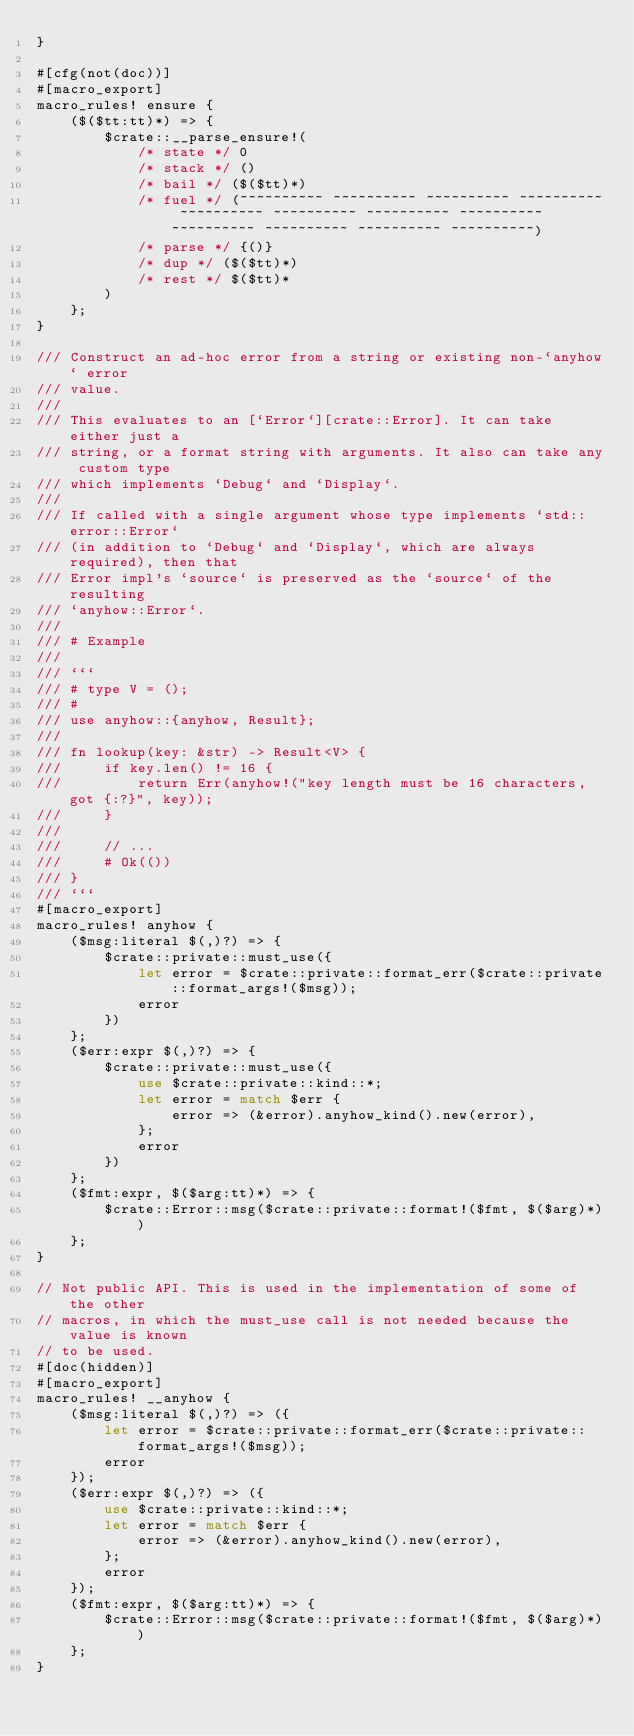<code> <loc_0><loc_0><loc_500><loc_500><_Rust_>}

#[cfg(not(doc))]
#[macro_export]
macro_rules! ensure {
    ($($tt:tt)*) => {
        $crate::__parse_ensure!(
            /* state */ 0
            /* stack */ ()
            /* bail */ ($($tt)*)
            /* fuel */ (~~~~~~~~~~ ~~~~~~~~~~ ~~~~~~~~~~ ~~~~~~~~~~ ~~~~~~~~~~ ~~~~~~~~~~ ~~~~~~~~~~ ~~~~~~~~~~ ~~~~~~~~~~ ~~~~~~~~~~ ~~~~~~~~~~ ~~~~~~~~~~)
            /* parse */ {()}
            /* dup */ ($($tt)*)
            /* rest */ $($tt)*
        )
    };
}

/// Construct an ad-hoc error from a string or existing non-`anyhow` error
/// value.
///
/// This evaluates to an [`Error`][crate::Error]. It can take either just a
/// string, or a format string with arguments. It also can take any custom type
/// which implements `Debug` and `Display`.
///
/// If called with a single argument whose type implements `std::error::Error`
/// (in addition to `Debug` and `Display`, which are always required), then that
/// Error impl's `source` is preserved as the `source` of the resulting
/// `anyhow::Error`.
///
/// # Example
///
/// ```
/// # type V = ();
/// #
/// use anyhow::{anyhow, Result};
///
/// fn lookup(key: &str) -> Result<V> {
///     if key.len() != 16 {
///         return Err(anyhow!("key length must be 16 characters, got {:?}", key));
///     }
///
///     // ...
///     # Ok(())
/// }
/// ```
#[macro_export]
macro_rules! anyhow {
    ($msg:literal $(,)?) => {
        $crate::private::must_use({
            let error = $crate::private::format_err($crate::private::format_args!($msg));
            error
        })
    };
    ($err:expr $(,)?) => {
        $crate::private::must_use({
            use $crate::private::kind::*;
            let error = match $err {
                error => (&error).anyhow_kind().new(error),
            };
            error
        })
    };
    ($fmt:expr, $($arg:tt)*) => {
        $crate::Error::msg($crate::private::format!($fmt, $($arg)*))
    };
}

// Not public API. This is used in the implementation of some of the other
// macros, in which the must_use call is not needed because the value is known
// to be used.
#[doc(hidden)]
#[macro_export]
macro_rules! __anyhow {
    ($msg:literal $(,)?) => ({
        let error = $crate::private::format_err($crate::private::format_args!($msg));
        error
    });
    ($err:expr $(,)?) => ({
        use $crate::private::kind::*;
        let error = match $err {
            error => (&error).anyhow_kind().new(error),
        };
        error
    });
    ($fmt:expr, $($arg:tt)*) => {
        $crate::Error::msg($crate::private::format!($fmt, $($arg)*))
    };
}
</code> 